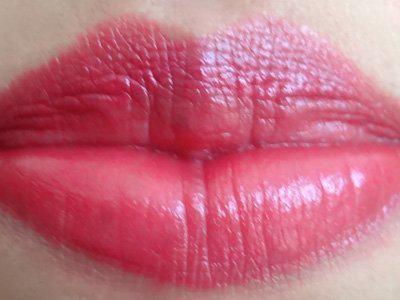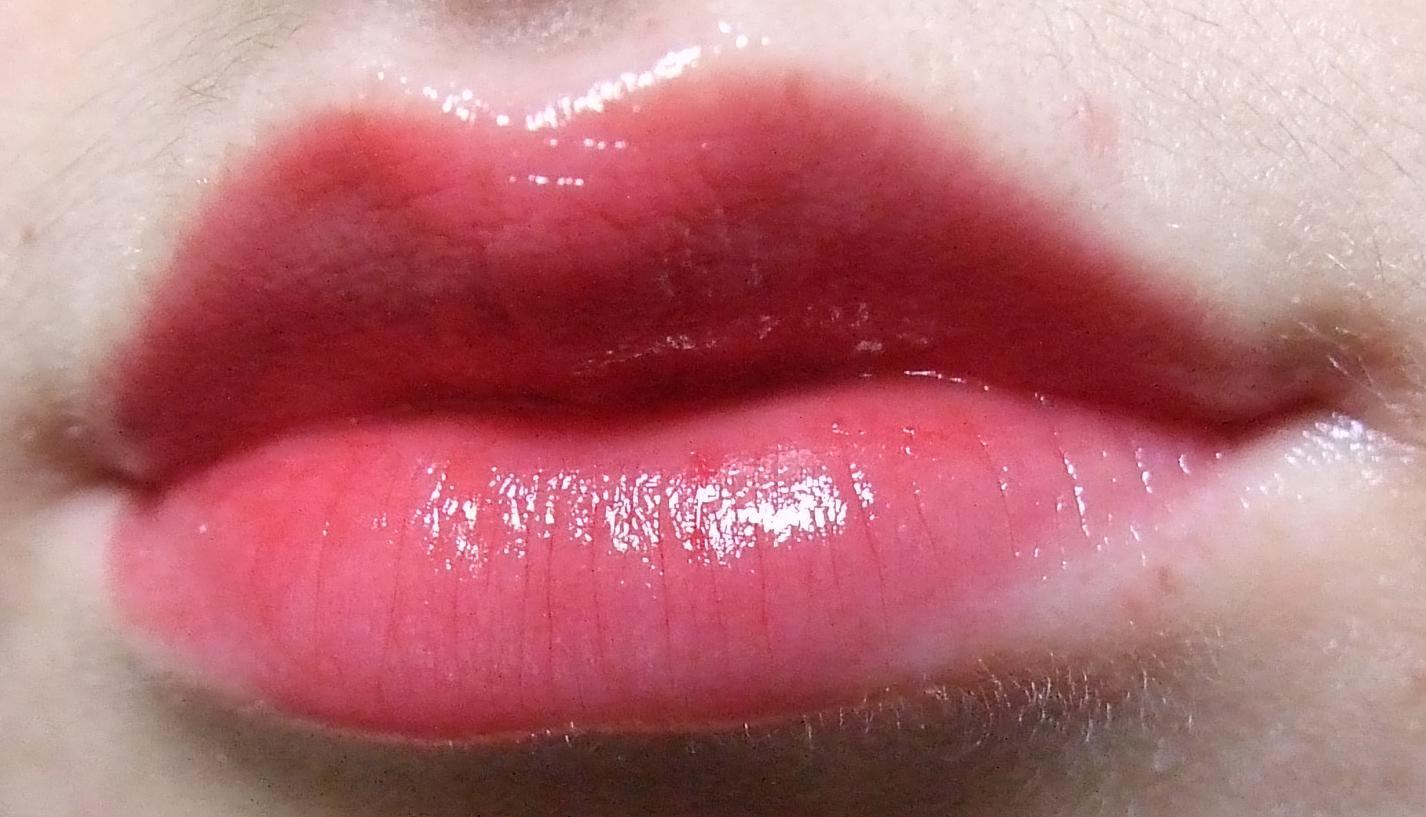The first image is the image on the left, the second image is the image on the right. Assess this claim about the two images: "Im at least one image there is are a set of pink peach lips that are closed.". Correct or not? Answer yes or no. Yes. The first image is the image on the left, the second image is the image on the right. For the images displayed, is the sentence "The lips on the right have a more lavender tint than the lips on the left, which are more coral colored." factually correct? Answer yes or no. No. 